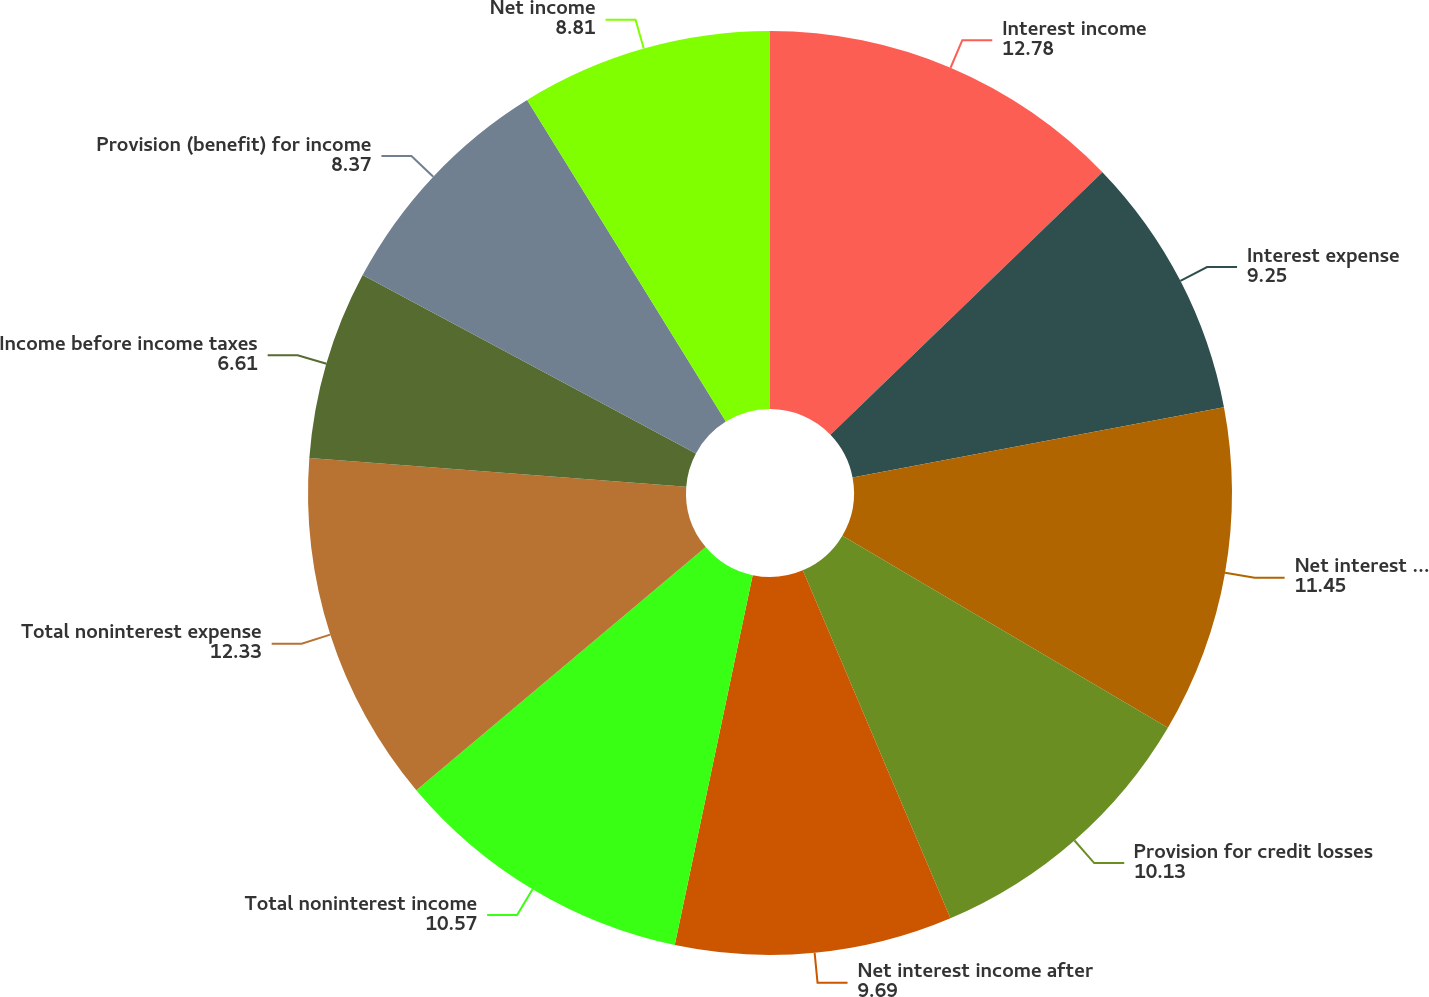Convert chart. <chart><loc_0><loc_0><loc_500><loc_500><pie_chart><fcel>Interest income<fcel>Interest expense<fcel>Net interest income<fcel>Provision for credit losses<fcel>Net interest income after<fcel>Total noninterest income<fcel>Total noninterest expense<fcel>Income before income taxes<fcel>Provision (benefit) for income<fcel>Net income<nl><fcel>12.78%<fcel>9.25%<fcel>11.45%<fcel>10.13%<fcel>9.69%<fcel>10.57%<fcel>12.33%<fcel>6.61%<fcel>8.37%<fcel>8.81%<nl></chart> 